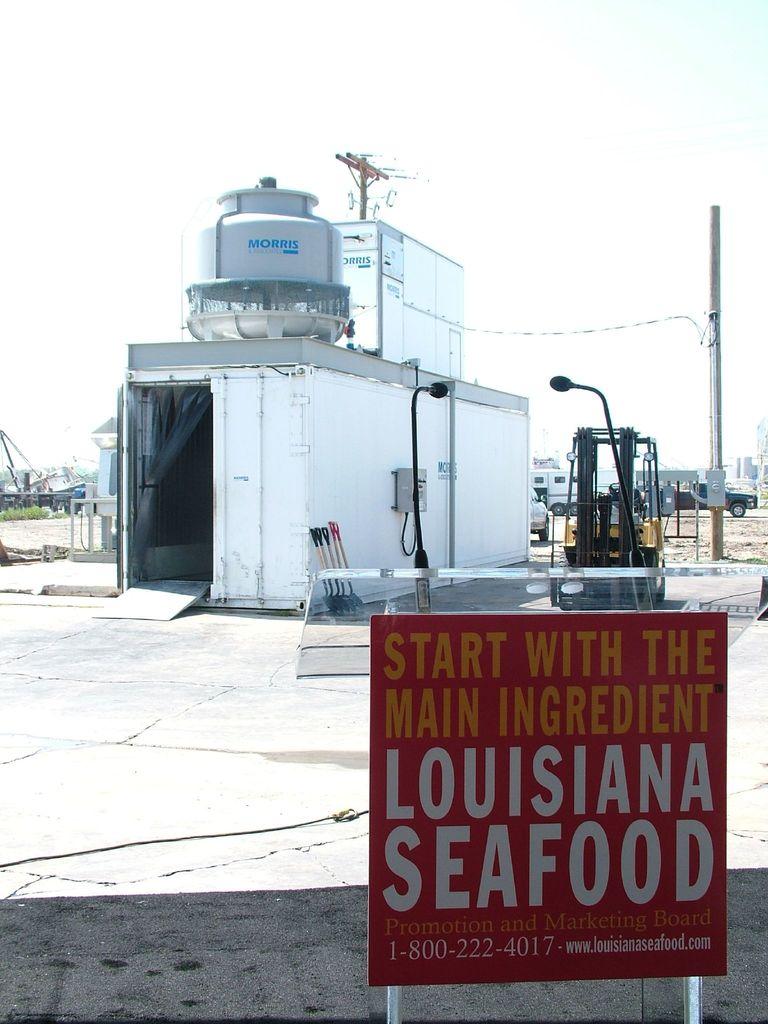What state is seafood from?
Provide a succinct answer. Louisiana. What is louisiana seafood's company phone number?
Provide a short and direct response. 1-800-222-4017. 